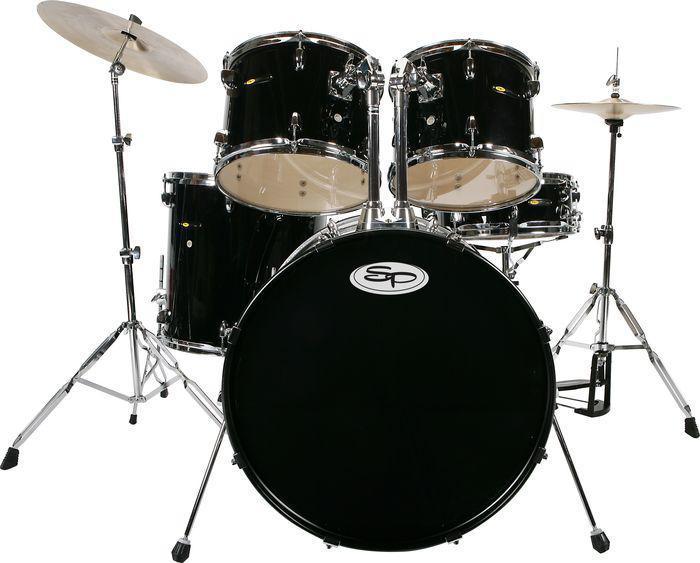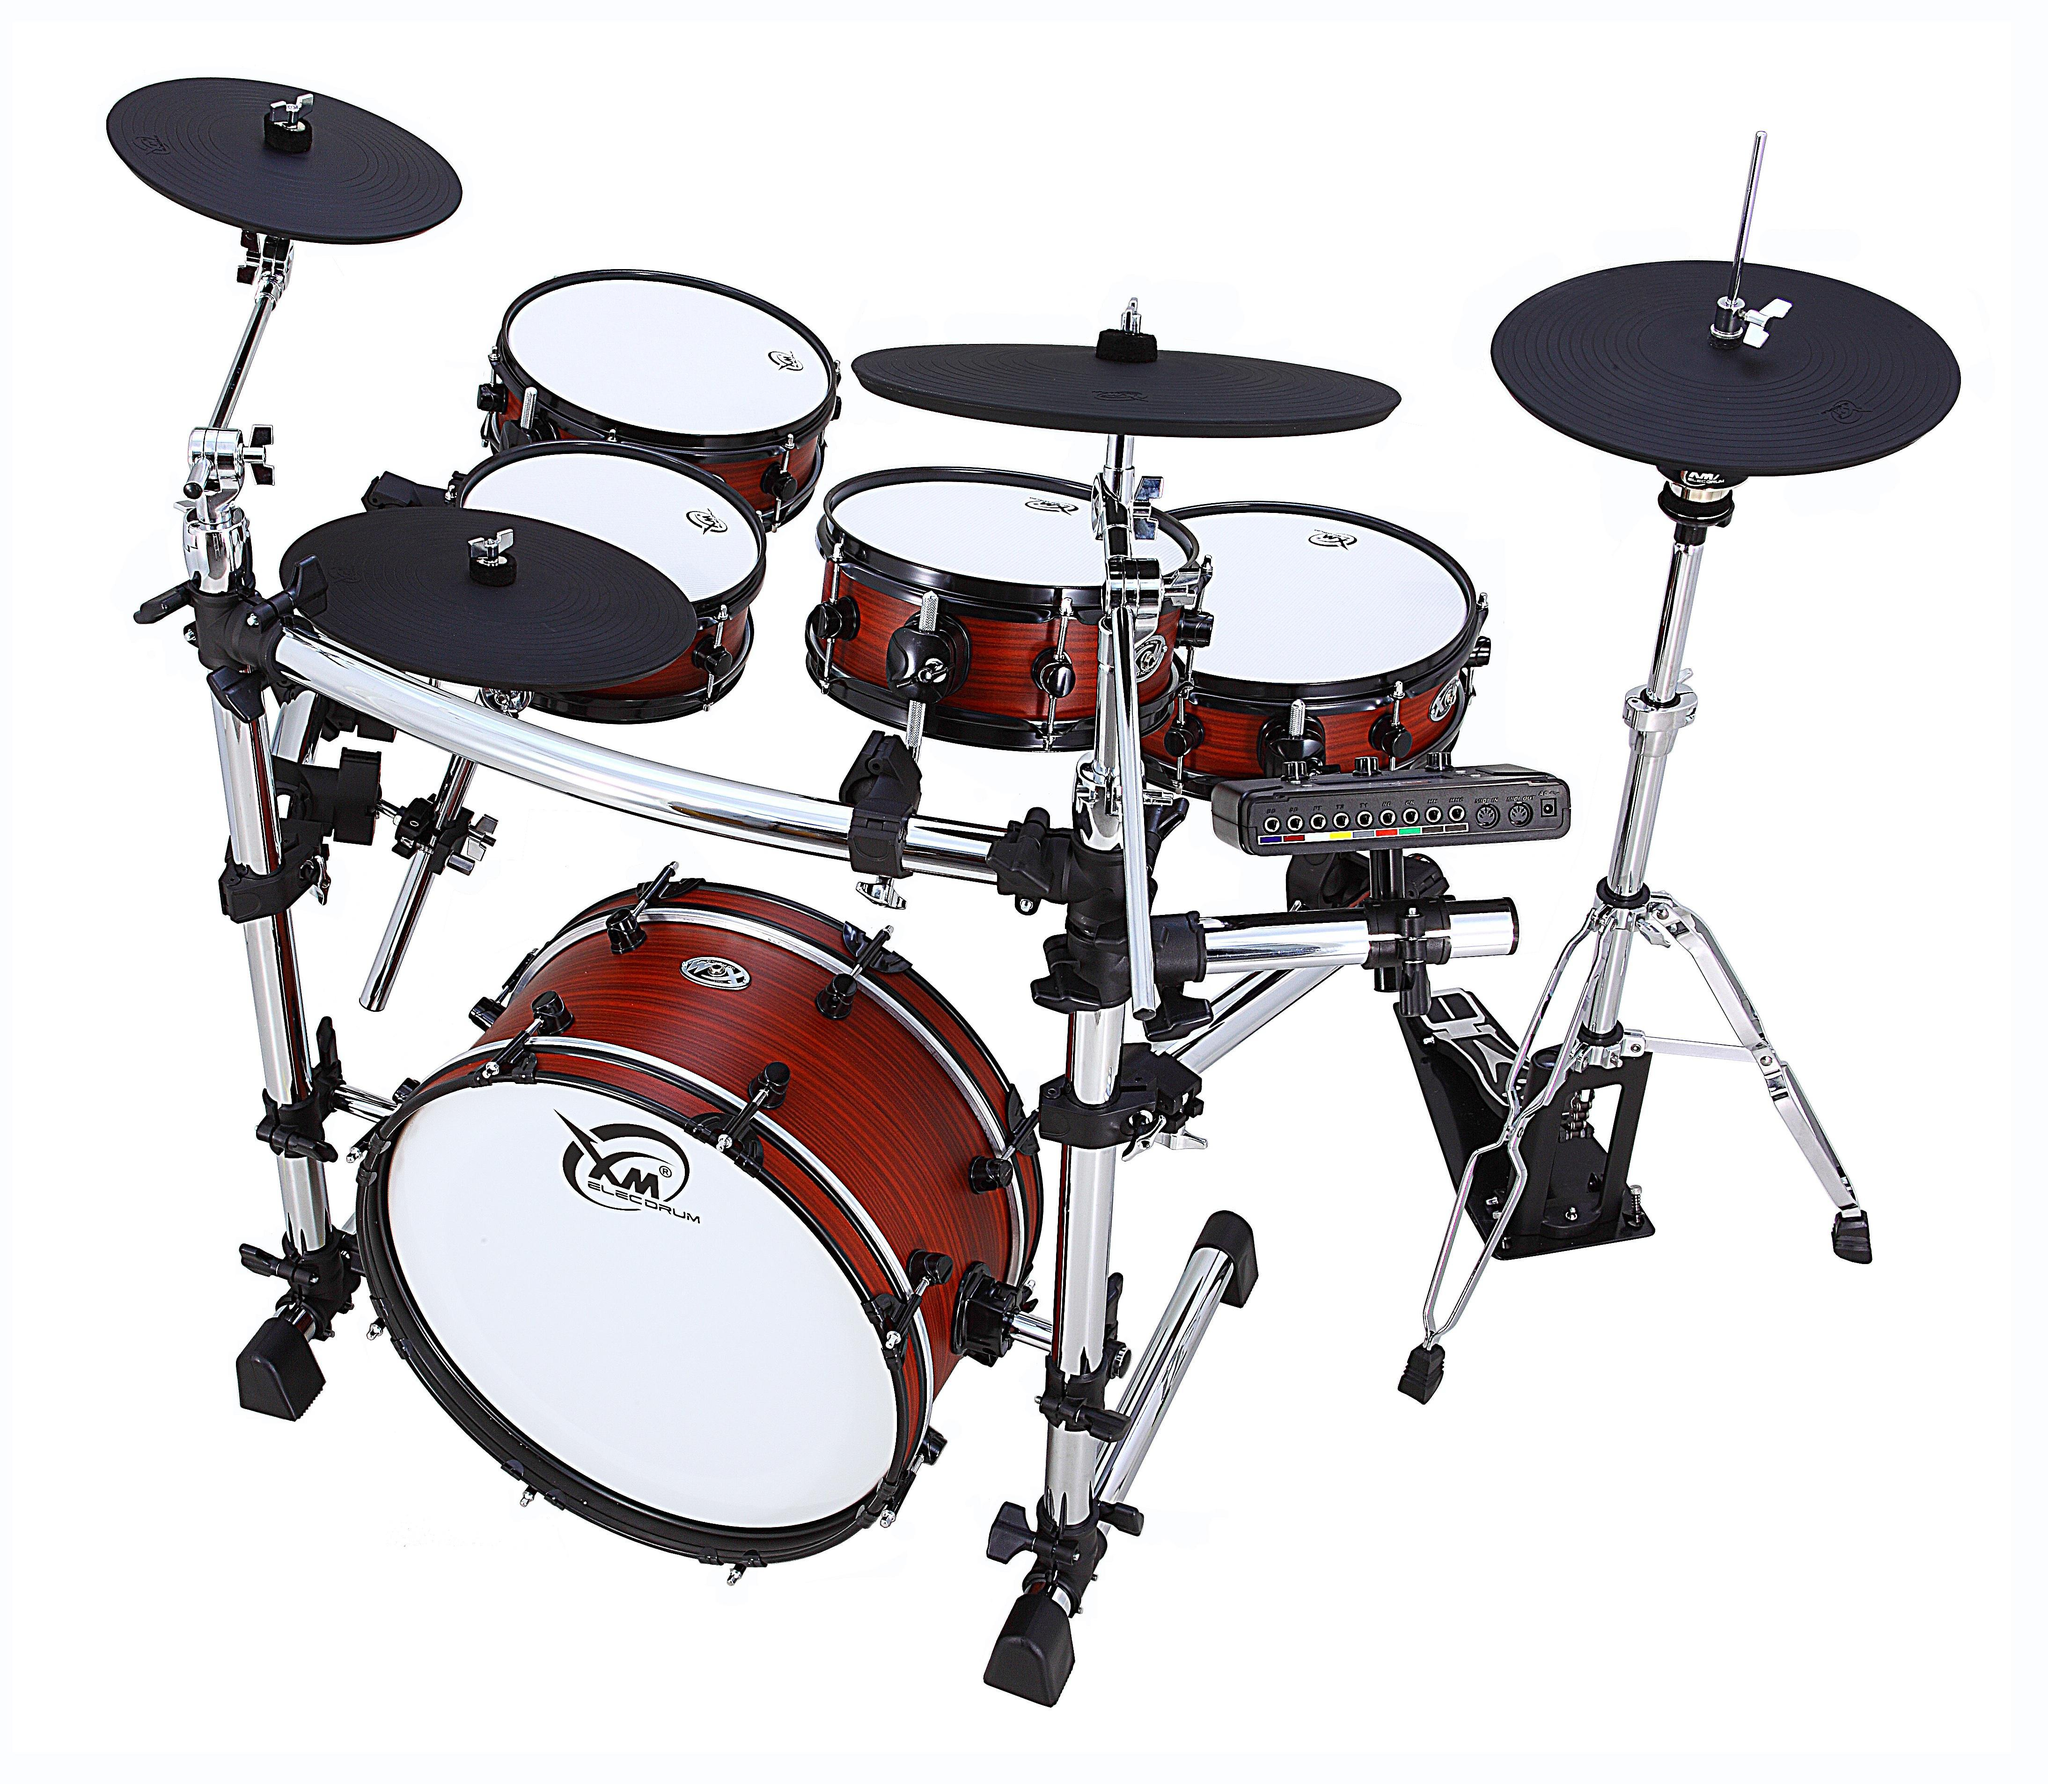The first image is the image on the left, the second image is the image on the right. Analyze the images presented: Is the assertion "The kick drum skin in the left image is black." valid? Answer yes or no. Yes. The first image is the image on the left, the second image is the image on the right. Analyze the images presented: Is the assertion "One image features a drum kit with the central large drum showing a black round side, and the other image features a drum kit with the central large drum showing a round white side." valid? Answer yes or no. Yes. 